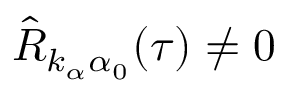Convert formula to latex. <formula><loc_0><loc_0><loc_500><loc_500>\hat { R } _ { k _ { \alpha } \alpha _ { 0 } } ( \tau ) \ne 0</formula> 